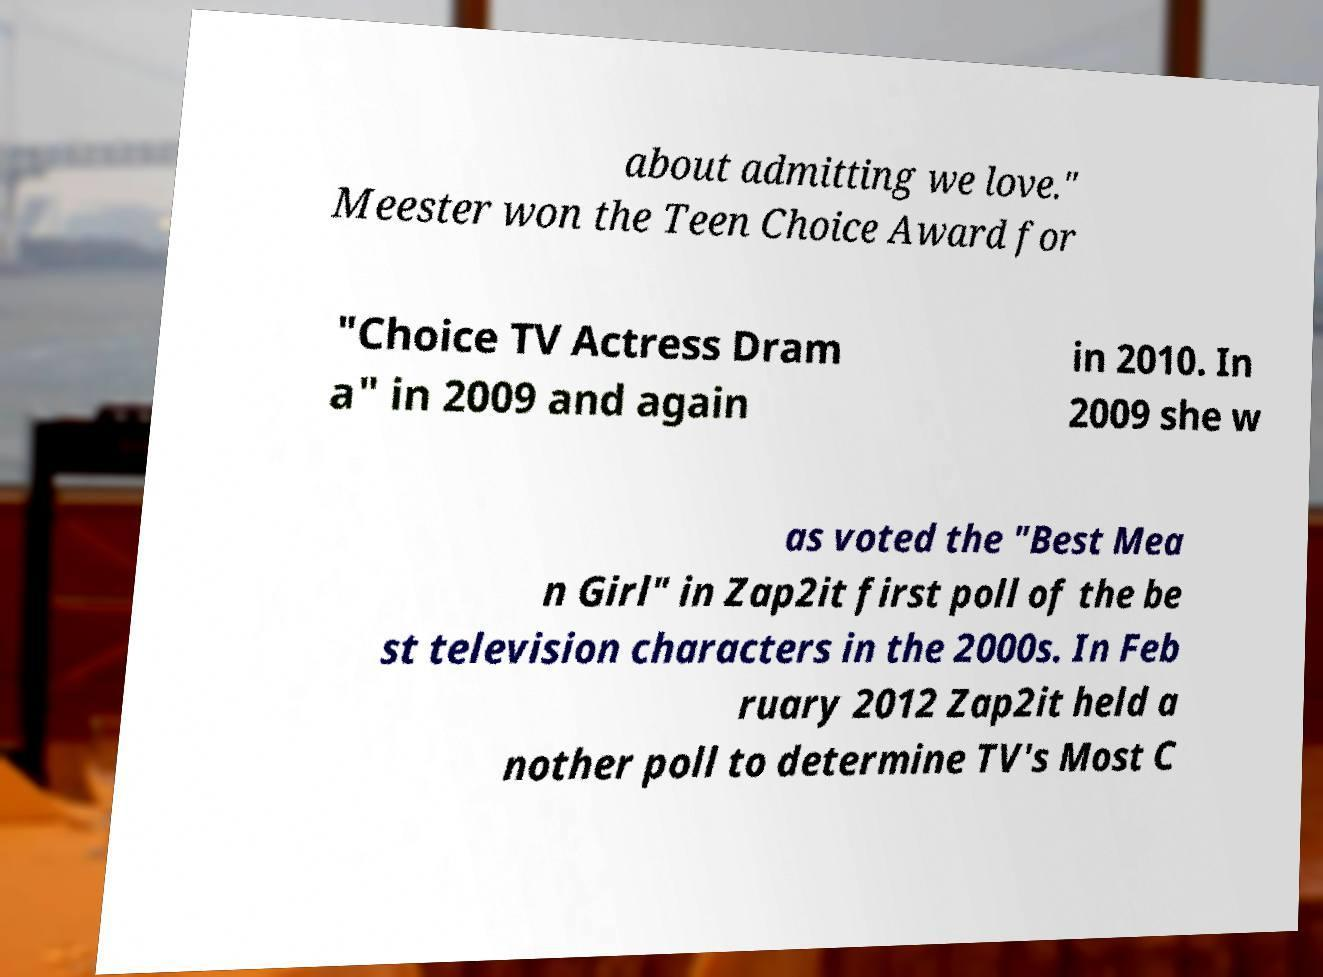Could you assist in decoding the text presented in this image and type it out clearly? about admitting we love." Meester won the Teen Choice Award for "Choice TV Actress Dram a" in 2009 and again in 2010. In 2009 she w as voted the "Best Mea n Girl" in Zap2it first poll of the be st television characters in the 2000s. In Feb ruary 2012 Zap2it held a nother poll to determine TV's Most C 